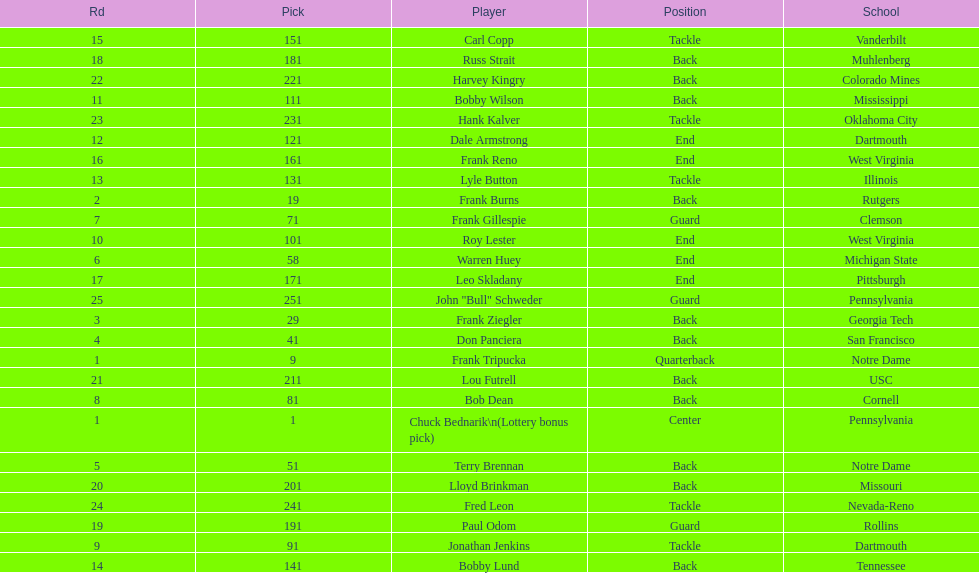Who was the player that the team drafted after bob dean? Jonathan Jenkins. 